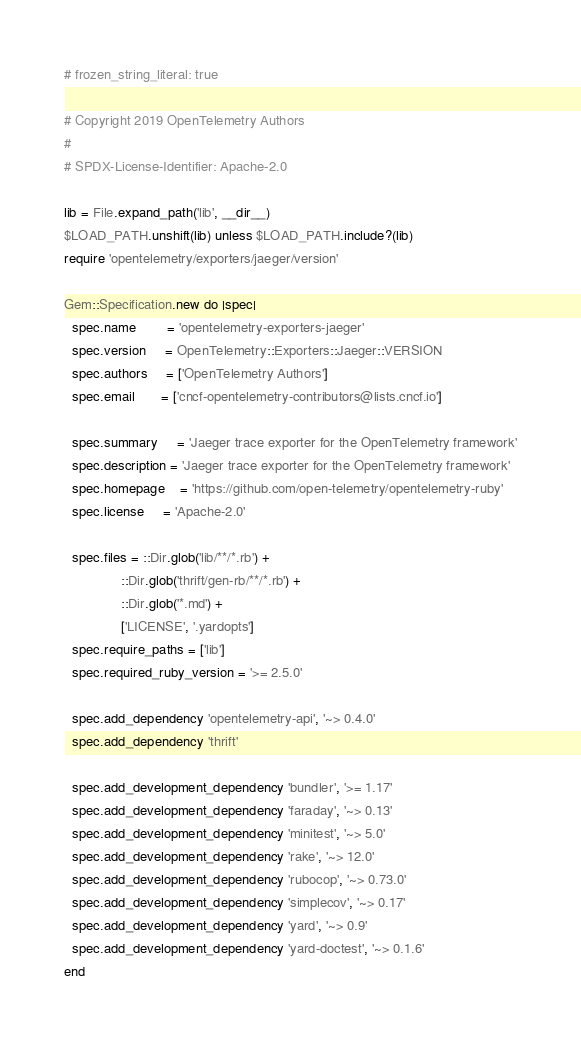<code> <loc_0><loc_0><loc_500><loc_500><_Ruby_># frozen_string_literal: true

# Copyright 2019 OpenTelemetry Authors
#
# SPDX-License-Identifier: Apache-2.0

lib = File.expand_path('lib', __dir__)
$LOAD_PATH.unshift(lib) unless $LOAD_PATH.include?(lib)
require 'opentelemetry/exporters/jaeger/version'

Gem::Specification.new do |spec|
  spec.name        = 'opentelemetry-exporters-jaeger'
  spec.version     = OpenTelemetry::Exporters::Jaeger::VERSION
  spec.authors     = ['OpenTelemetry Authors']
  spec.email       = ['cncf-opentelemetry-contributors@lists.cncf.io']

  spec.summary     = 'Jaeger trace exporter for the OpenTelemetry framework'
  spec.description = 'Jaeger trace exporter for the OpenTelemetry framework'
  spec.homepage    = 'https://github.com/open-telemetry/opentelemetry-ruby'
  spec.license     = 'Apache-2.0'

  spec.files = ::Dir.glob('lib/**/*.rb') +
               ::Dir.glob('thrift/gen-rb/**/*.rb') +
               ::Dir.glob('*.md') +
               ['LICENSE', '.yardopts']
  spec.require_paths = ['lib']
  spec.required_ruby_version = '>= 2.5.0'

  spec.add_dependency 'opentelemetry-api', '~> 0.4.0'
  spec.add_dependency 'thrift'

  spec.add_development_dependency 'bundler', '>= 1.17'
  spec.add_development_dependency 'faraday', '~> 0.13'
  spec.add_development_dependency 'minitest', '~> 5.0'
  spec.add_development_dependency 'rake', '~> 12.0'
  spec.add_development_dependency 'rubocop', '~> 0.73.0'
  spec.add_development_dependency 'simplecov', '~> 0.17'
  spec.add_development_dependency 'yard', '~> 0.9'
  spec.add_development_dependency 'yard-doctest', '~> 0.1.6'
end
</code> 